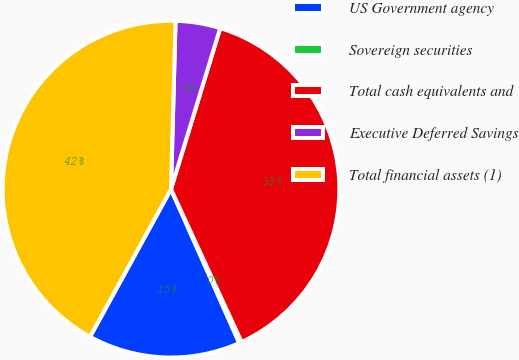<chart> <loc_0><loc_0><loc_500><loc_500><pie_chart><fcel>US Government agency<fcel>Sovereign securities<fcel>Total cash equivalents and<fcel>Executive Deferred Savings<fcel>Total financial assets (1)<nl><fcel>14.63%<fcel>0.24%<fcel>38.39%<fcel>4.29%<fcel>42.45%<nl></chart> 